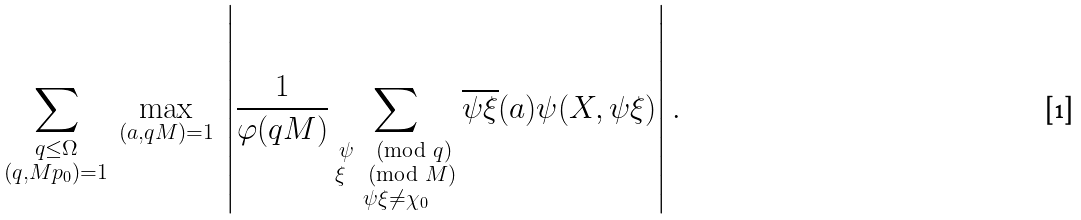<formula> <loc_0><loc_0><loc_500><loc_500>\sum _ { \substack { q \leq \Omega \\ ( q , M p _ { 0 } ) = 1 } } \, \max _ { ( a , q M ) = 1 } \, \left | \frac { 1 } { \varphi ( q M ) } \sum _ { \substack { \psi \pmod { q } \\ \xi \pmod { M } \\ \psi \xi \neq \chi _ { 0 } } } \overline { \psi \xi } ( a ) \psi ( X , \psi \xi ) \right | .</formula> 